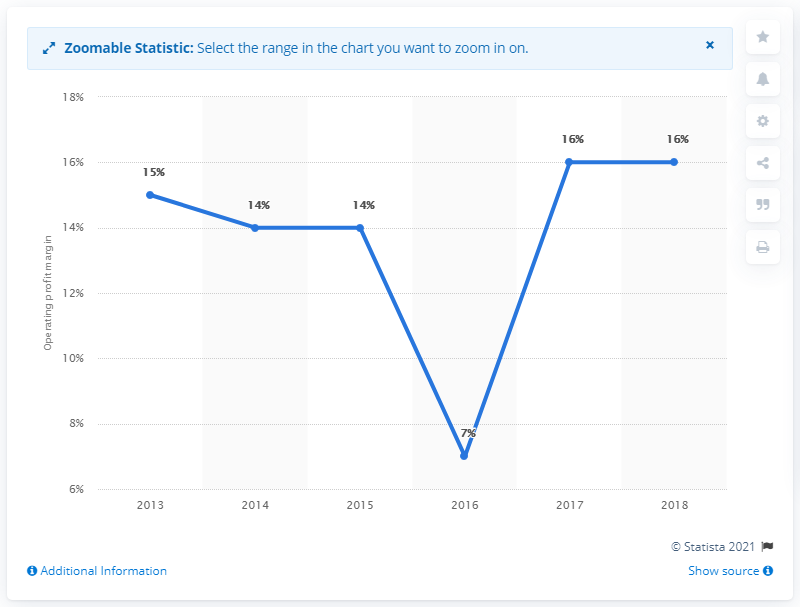Highlight a few significant elements in this photo. The operating profit margin is a key indicator of a company's profitability and can provide valuable insights into the financial performance of a sector. 